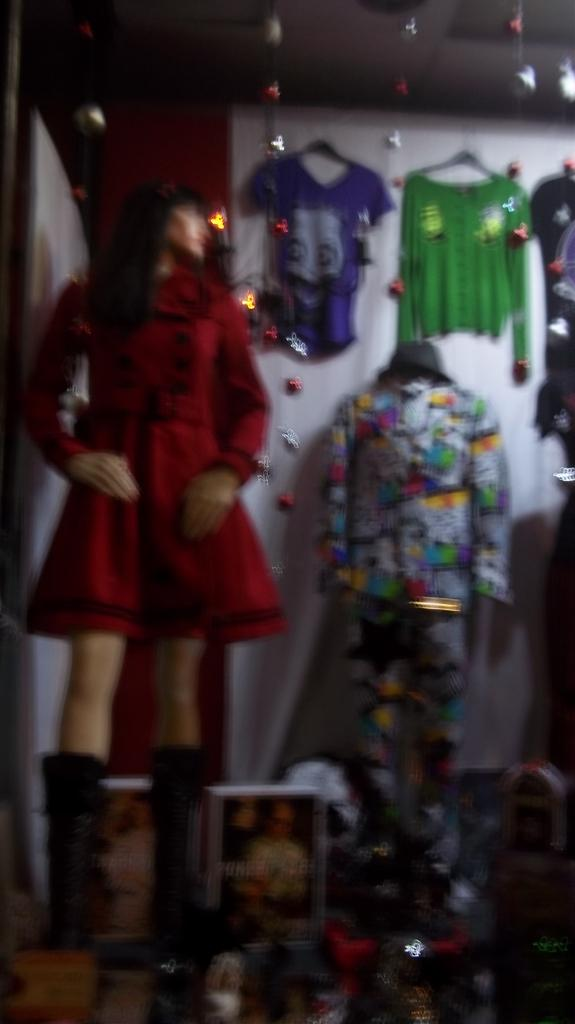What type of objects can be seen in the image? There are mannequins in the image. What are the mannequins wearing? Clothes are present in the image. What can be seen in the background of the image? Decor is visible in the image, and there is a wall in the image. What parts of the building are visible in the image? The roof is visible at the top of the image, and the floor is visible at the bottom of the image. Can you see any jellyfish swimming in the image? No, there are no jellyfish present in the image. What type of bag is being used to carry the mannequins in the image? There is no bag visible in the image, as the mannequins are stationary and not being carried. 